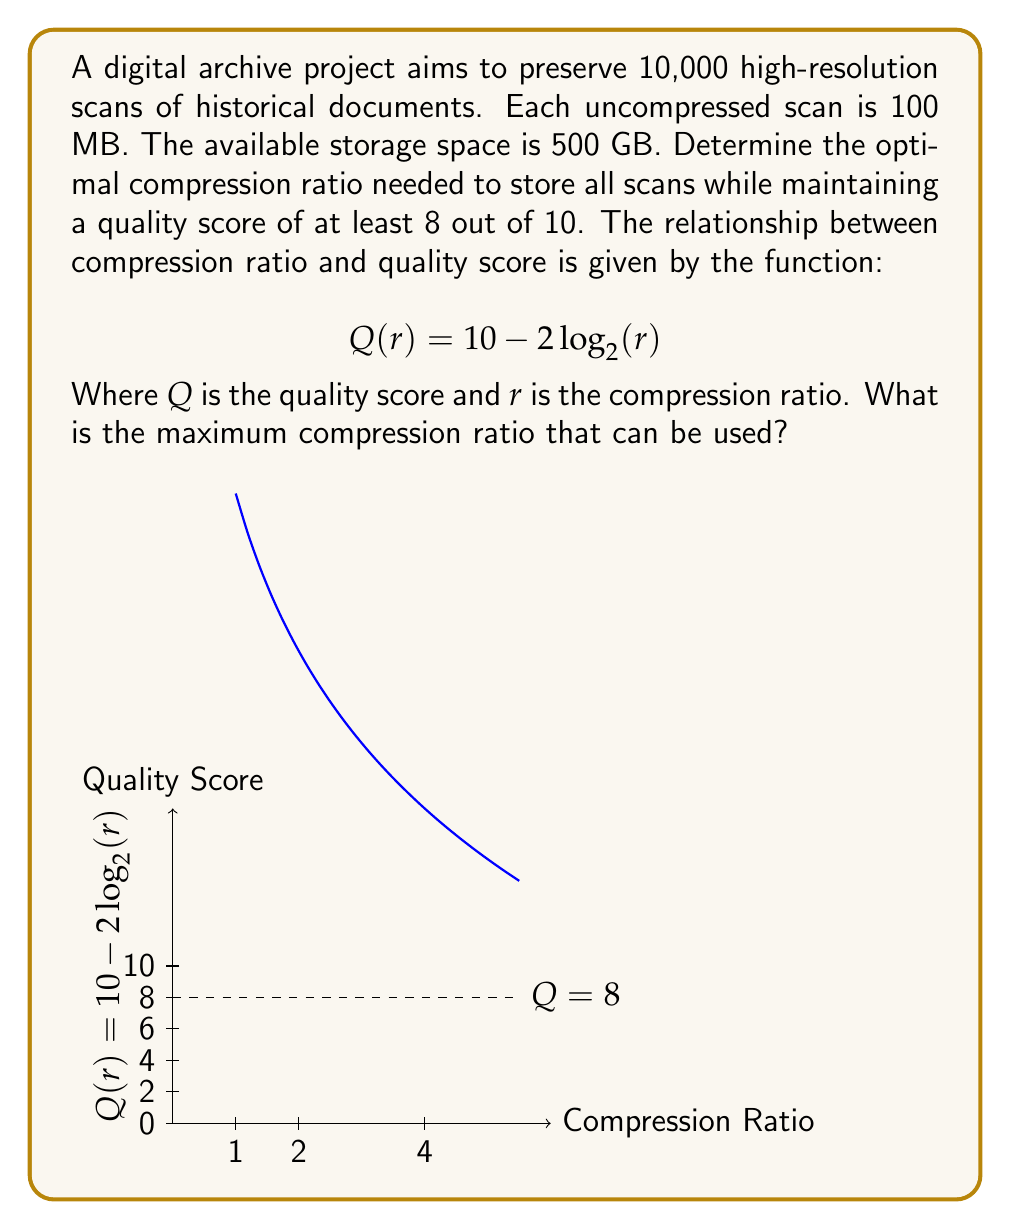Could you help me with this problem? Let's approach this step-by-step:

1) First, calculate the total uncompressed size of all scans:
   $10,000 \times 100 \text{ MB} = 1,000,000 \text{ MB} = 1,000 \text{ GB}$

2) The available storage is 500 GB, so we need to compress the data by at least:
   $\frac{1,000 \text{ GB}}{500 \text{ GB}} = 2$ times

3) Now, we need to find the maximum compression ratio that maintains a quality score of at least 8. We can use the given equation:
   $$Q(r) = 10 - 2\log_2(r)$$

4) We want $Q(r) \geq 8$, so:
   $$8 \leq 10 - 2\log_2(r)$$

5) Solving for $r$:
   $$-2 \leq -2\log_2(r)$$
   $$1 \geq \log_2(r)$$
   $$2^1 \geq r$$
   $$2 \geq r$$

6) This means the maximum compression ratio we can use is 2, which coincidentally matches the minimum compression we need to fit the data in the available storage.

7) Verify that this meets our storage requirement:
   $\frac{1,000 \text{ GB}}{2} = 500 \text{ GB}$, which equals our available storage.

Therefore, the optimal compression ratio is 2.
Answer: 2 